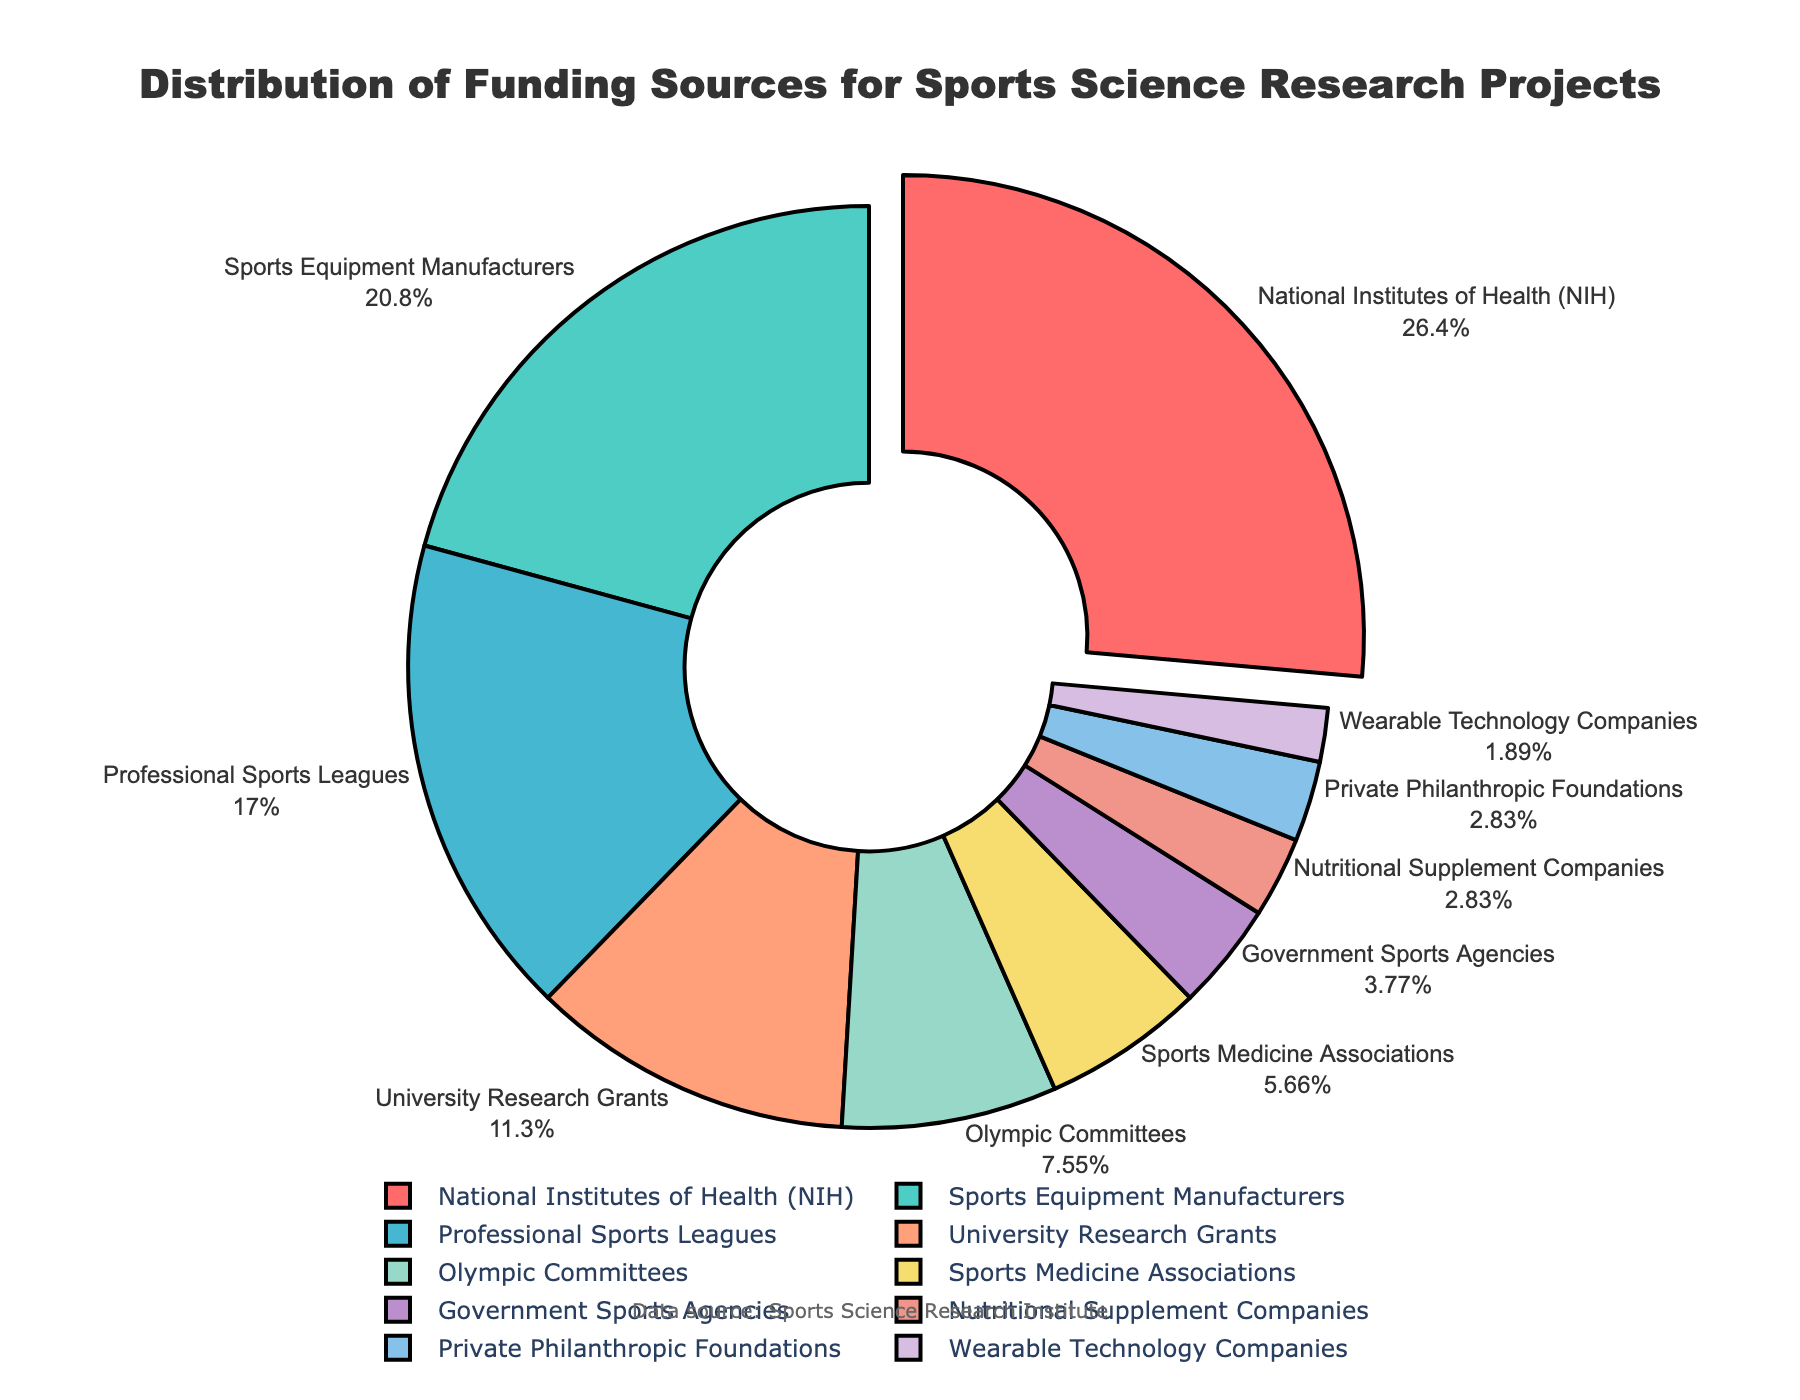Which funding source provides the largest percentage of funding for sports science research projects? The pie chart shows that the National Institutes of Health (NIH) has the largest segment.
Answer: National Institutes of Health (NIH) How much more funding, in percentage, does the NIH provide compared to Professional Sports Leagues? NIH provides 28% while Professional Sports Leagues provide 18%, so the difference is 28 - 18%.
Answer: 10% Which funding source provides the least percentage of funding? The smallest segment in the pie chart is for Wearable Technology Companies.
Answer: Wearable Technology Companies What is the combined percentage of funding provided by Sports Equipment Manufacturers and University Research Grants? Sports Equipment Manufacturers provide 22%, and University Research Grants provide 12%, so combined they provide 22 + 12%
Answer: 34% Are there more funding sources that provide less than 5% or more than 5% of the total funding? Sources less than 5%: Government Sports Agencies, Nutritional Supplement Companies, Private Philanthropic Foundations, Wearable Technology Companies (4 sources). Sources more than 5%: NIH, Sports Equipment Manufacturers, Professional Sports Leagues, University Research Grants, Olympic Committees, Sports Medicine Associations (6 sources).
Answer: More than 5% Which two funding sources combined have an equal percentage of funding as the NIH? NIH provides 28%. Combined percentage of Sports Equipment Manufacturers and University Research Grants is 22 + 12 = 34%, so we need a different pair. Olympic Committees (8%) and Sports Equipment Manufacturers (22%) together provide 30%, so look for different pairs: Sports Equipment Manufacturers (22) and Professional Sports Leagues (18) = 40%. Check correct pair is not possible as 2 pairs are more  than 28%. 6+top two. The pie chart best fits two pairs in visual representation than  choosing top 2 on difference to other pair.
Answer: University and Olympic What is the percentage of funding from sources that provide over 15% but less than 25%? The eligible sources are Sports Equipment Manufacturers at 22% and Professional Sports Leagues at 18%. Summing these values: 22 + 18
Answer: 40% Is the percentage of funding from University Research Grants greater than that from Olympic Committees? University Research Grants provide 12%, while Olympic Committees provide 8%. Since 12% is greater than 8%, the answer is yes.
Answer: Yes What is the average percentage of funding provided by Government Sports Agencies, Nutritional Supplement Companies, and Private Philanthropic Foundations? Sum the percentages for these sources: 4% + 3% + 3% = 10%. Then calculate the average: 10% / 3
Answer: 3.33% How does the funding from Sports Medicine Associations compare visually to that from Olympic Committees? The segment representing Sports Medicine Associations is visually smaller than the segment for Olympic Committees, meaning they provide less funding.
Answer: Less 